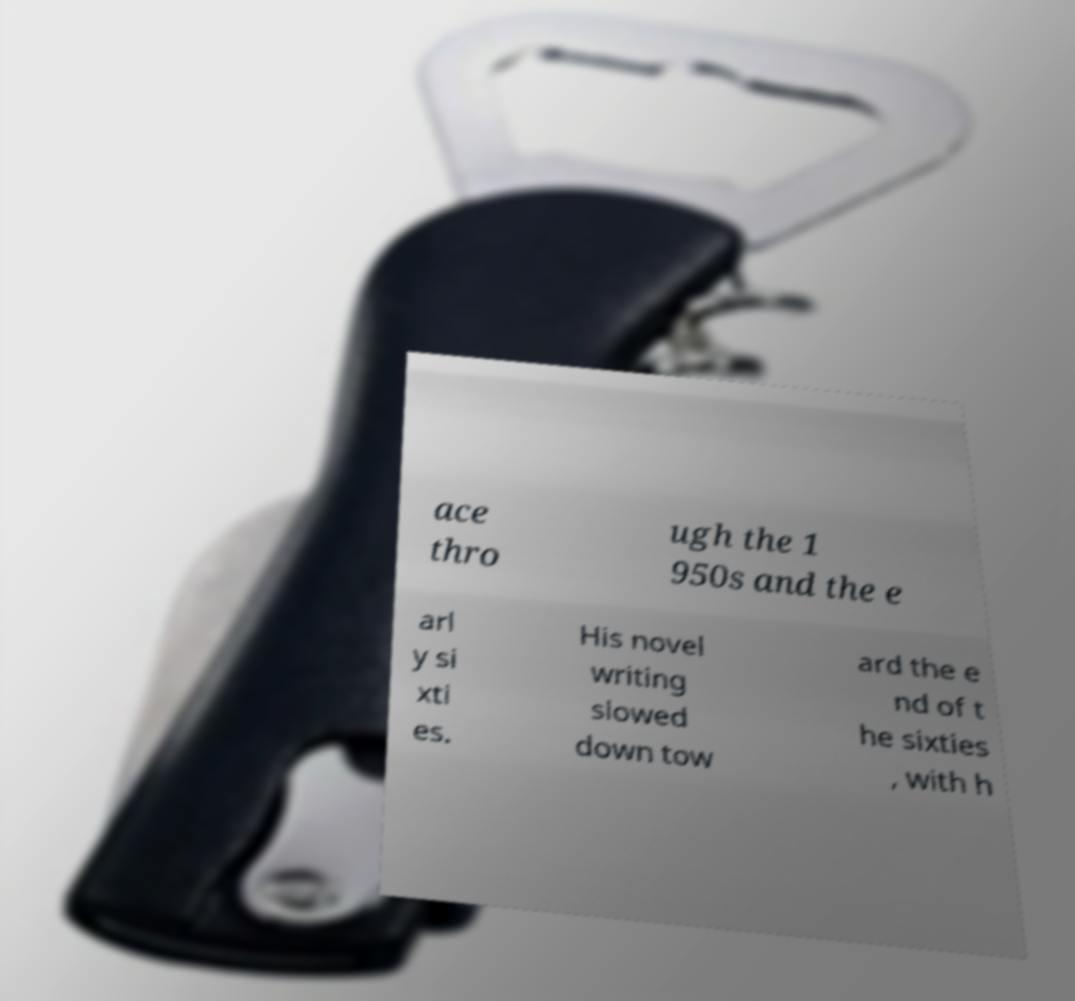Can you accurately transcribe the text from the provided image for me? ace thro ugh the 1 950s and the e arl y si xti es. His novel writing slowed down tow ard the e nd of t he sixties , with h 